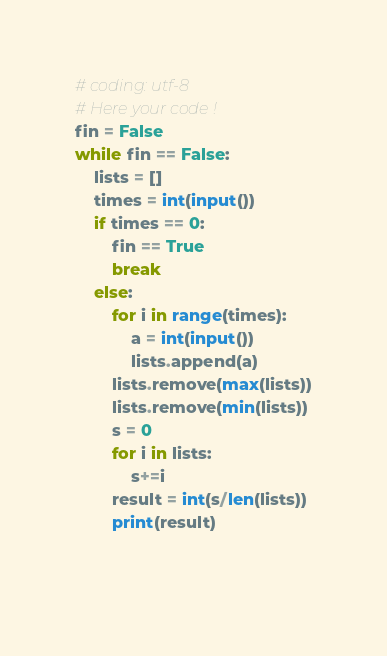Convert code to text. <code><loc_0><loc_0><loc_500><loc_500><_Python_># coding: utf-8
# Here your code !
fin = False
while fin == False:
    lists = []
    times = int(input())
    if times == 0:
        fin == True
        break
    else:
        for i in range(times):
            a = int(input())
            lists.append(a)
        lists.remove(max(lists))
        lists.remove(min(lists))
        s = 0
        for i in lists:
            s+=i
        result = int(s/len(lists))
        print(result)
    
    </code> 